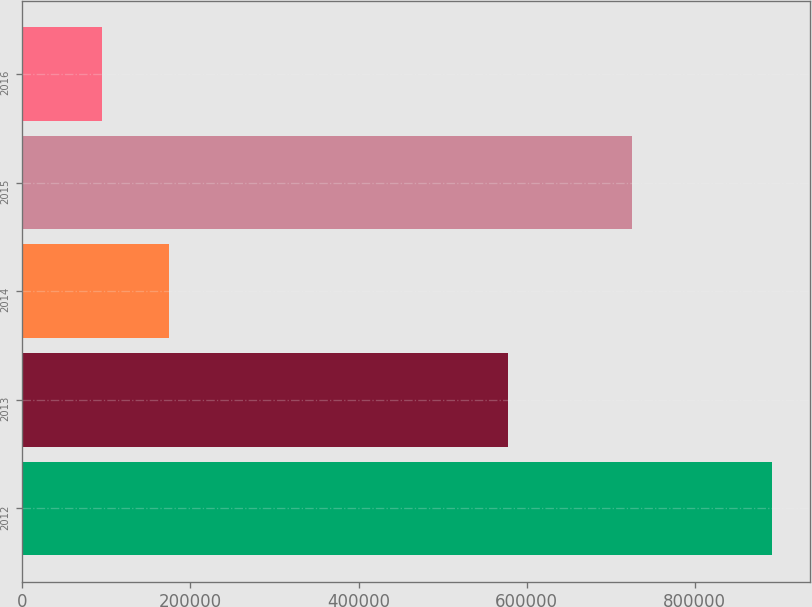Convert chart. <chart><loc_0><loc_0><loc_500><loc_500><bar_chart><fcel>2012<fcel>2013<fcel>2014<fcel>2015<fcel>2016<nl><fcel>892544<fcel>577664<fcel>174433<fcel>725223<fcel>94643<nl></chart> 